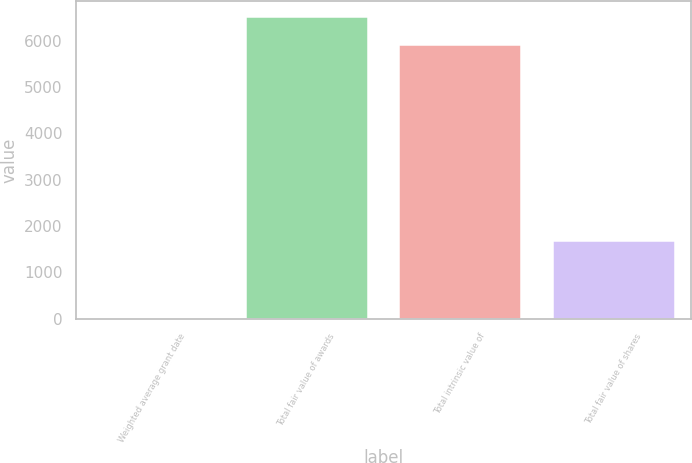<chart> <loc_0><loc_0><loc_500><loc_500><bar_chart><fcel>Weighted average grant date<fcel>Total fair value of awards<fcel>Total intrinsic value of<fcel>Total fair value of shares<nl><fcel>6.43<fcel>6529.66<fcel>5928<fcel>1694<nl></chart> 